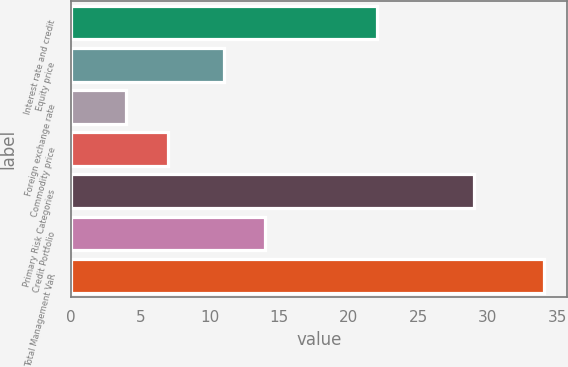Convert chart to OTSL. <chart><loc_0><loc_0><loc_500><loc_500><bar_chart><fcel>Interest rate and credit<fcel>Equity price<fcel>Foreign exchange rate<fcel>Commodity price<fcel>Primary Risk Categories<fcel>Credit Portfolio<fcel>Total Management VaR<nl><fcel>22<fcel>11<fcel>4<fcel>7<fcel>29<fcel>14<fcel>34<nl></chart> 